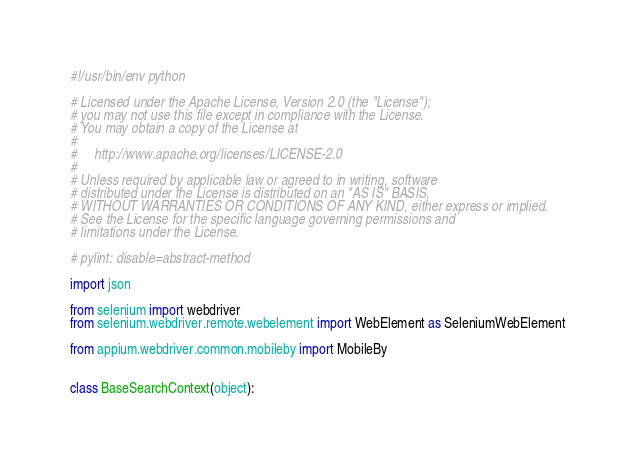<code> <loc_0><loc_0><loc_500><loc_500><_Python_>#!/usr/bin/env python

# Licensed under the Apache License, Version 2.0 (the "License");
# you may not use this file except in compliance with the License.
# You may obtain a copy of the License at
#
#     http://www.apache.org/licenses/LICENSE-2.0
#
# Unless required by applicable law or agreed to in writing, software
# distributed under the License is distributed on an "AS IS" BASIS,
# WITHOUT WARRANTIES OR CONDITIONS OF ANY KIND, either express or implied.
# See the License for the specific language governing permissions and
# limitations under the License.

# pylint: disable=abstract-method

import json

from selenium import webdriver
from selenium.webdriver.remote.webelement import WebElement as SeleniumWebElement

from appium.webdriver.common.mobileby import MobileBy


class BaseSearchContext(object):</code> 